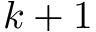<formula> <loc_0><loc_0><loc_500><loc_500>k + 1</formula> 